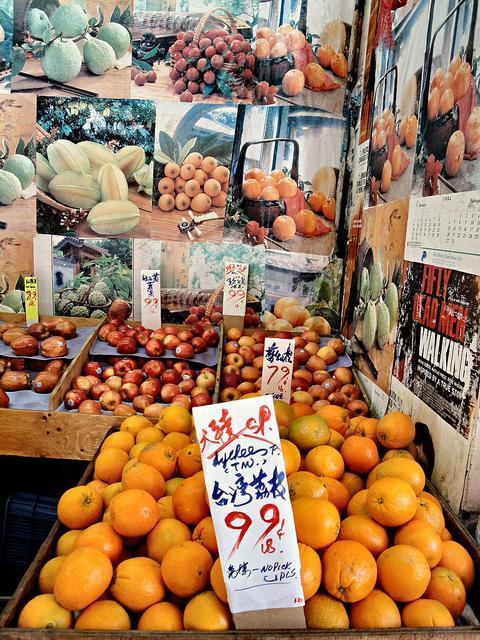How many oranges are there?
Give a very brief answer. 2. How many apples are in the photo?
Give a very brief answer. 3. 